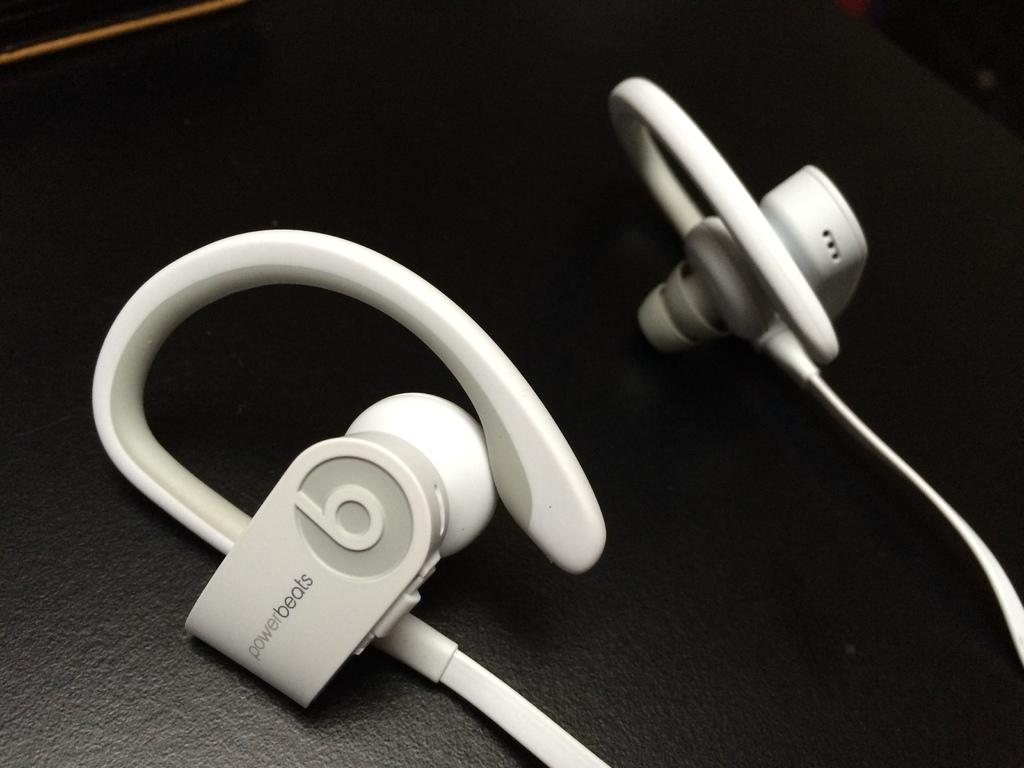What type of audio accessory is present in the image? There are earphones in the image. What is the color of the floor where the earphones are placed? The earphones are on the black color floor. Where can you find the kettle in the image? There is no kettle present in the image. What type of store is shown in the image? There is no store depicted in the image; it only features earphones on a black floor. 